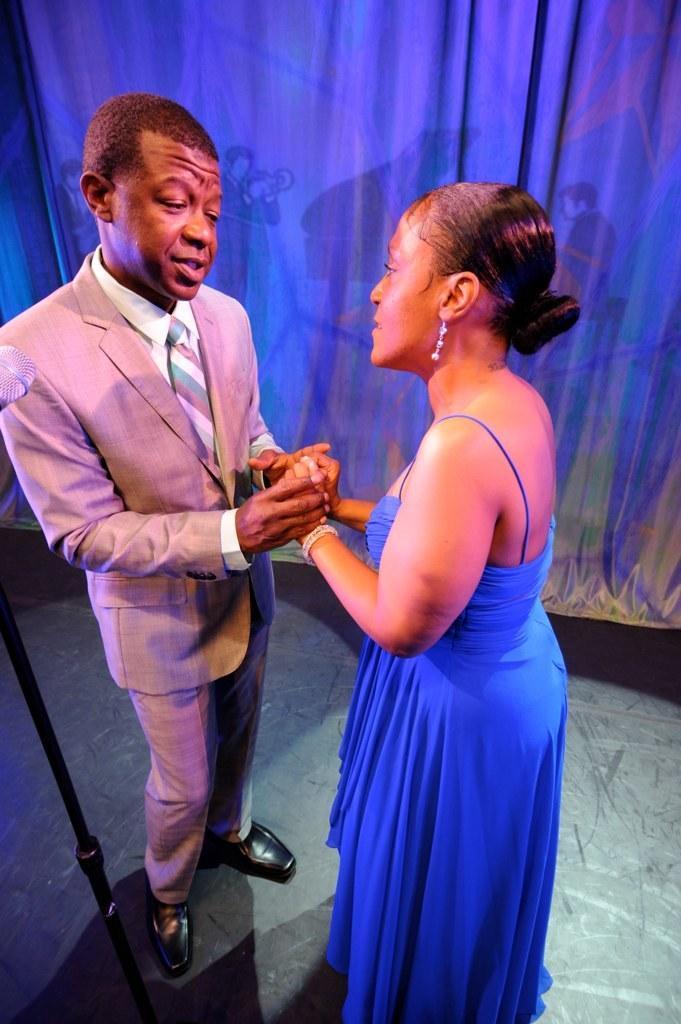In one or two sentences, can you explain what this image depicts? In this picture, we see a man and the women are standing. They are talking to each other. She is holding the hands of the man. Beside him, we see a stand. In the background, we see a sheet or a curtain in white color. 